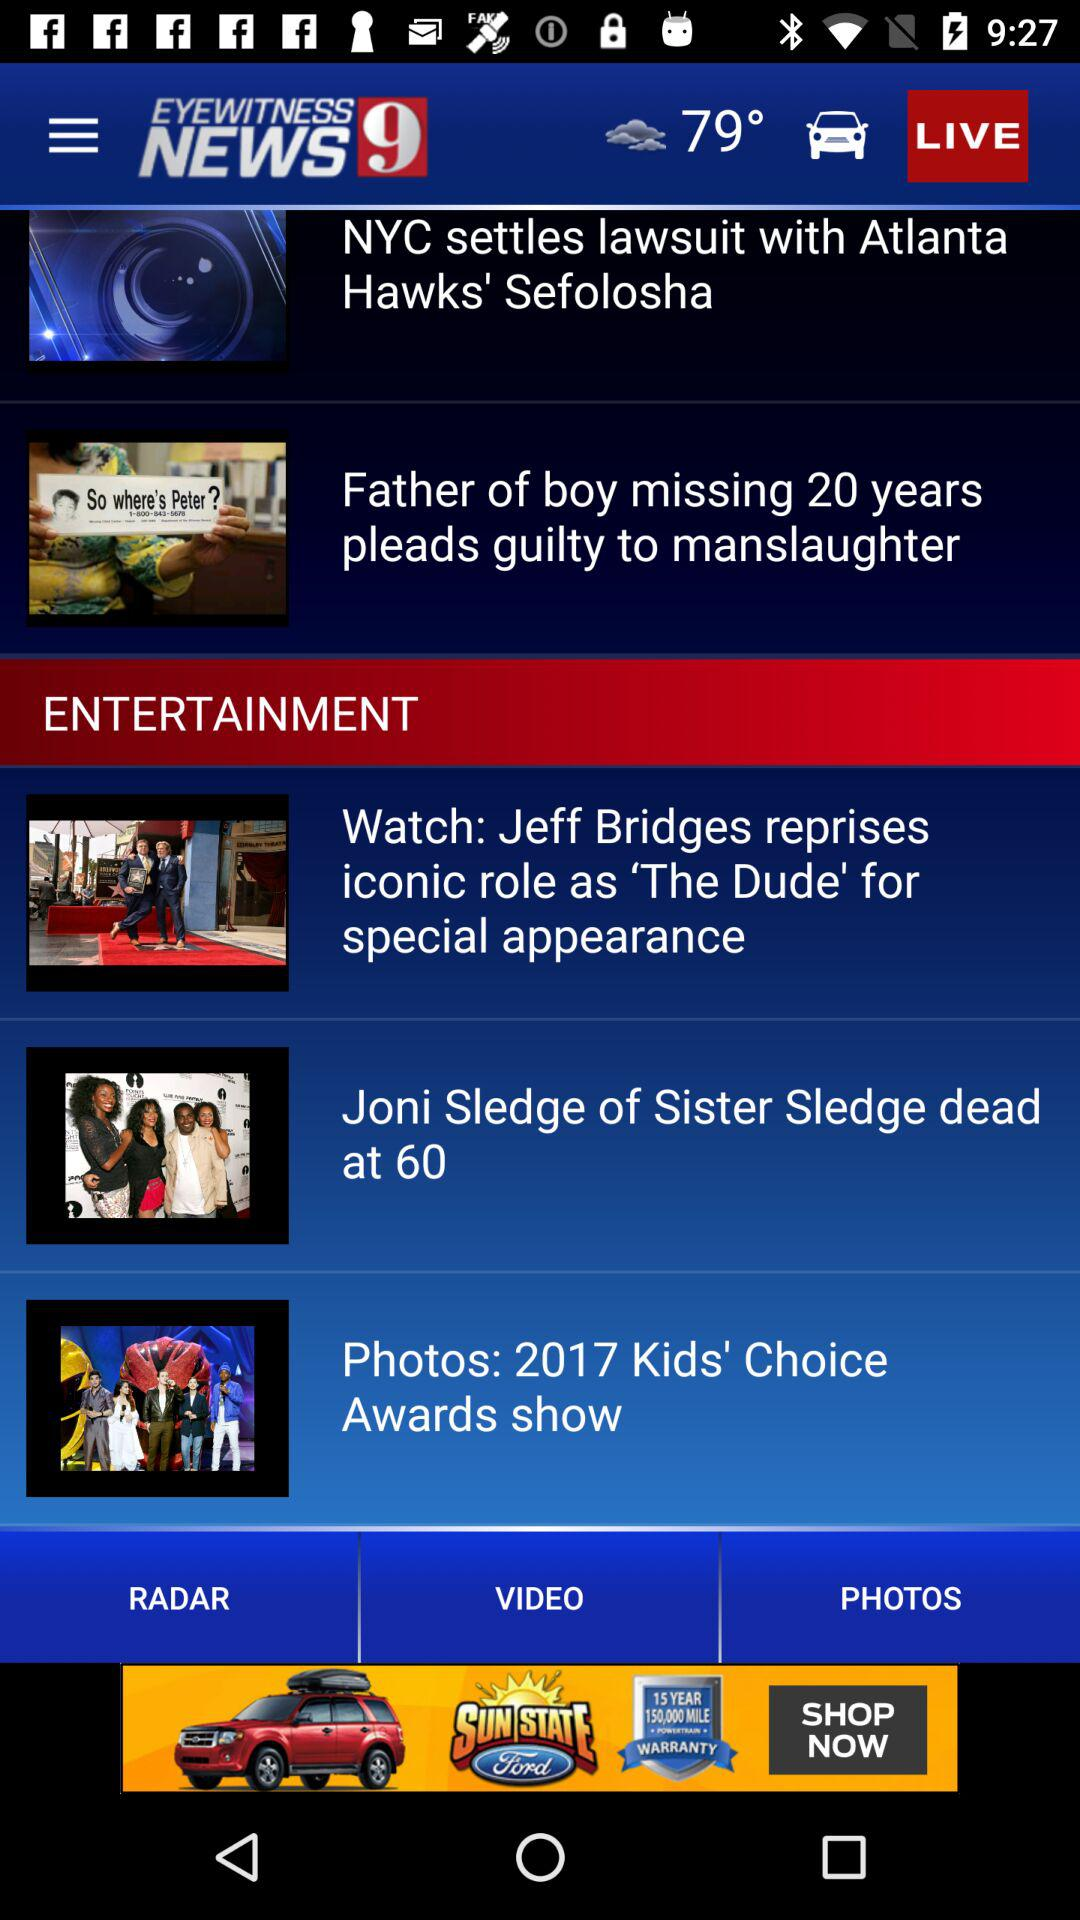What is the temperature? The temperature is 79°. 